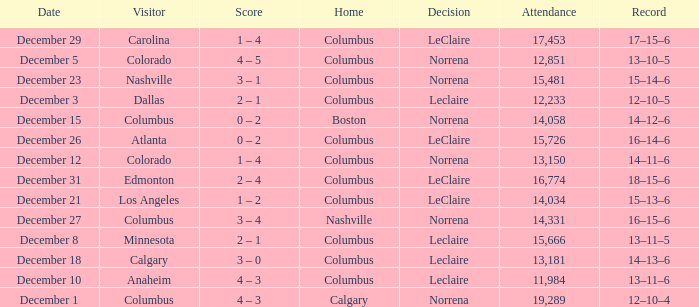What was the score with a 16–14–6 record? 0 – 2. 